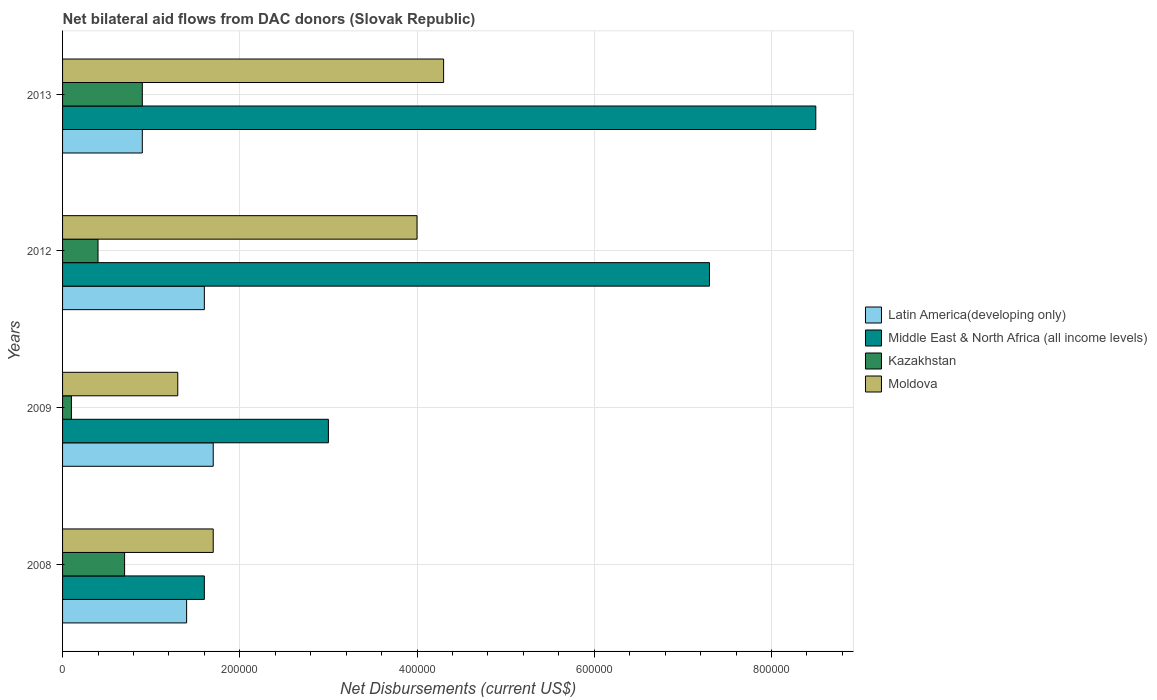How many different coloured bars are there?
Provide a short and direct response. 4. Are the number of bars per tick equal to the number of legend labels?
Give a very brief answer. Yes. Are the number of bars on each tick of the Y-axis equal?
Make the answer very short. Yes. What is the net bilateral aid flows in Middle East & North Africa (all income levels) in 2012?
Make the answer very short. 7.30e+05. Across all years, what is the minimum net bilateral aid flows in Middle East & North Africa (all income levels)?
Keep it short and to the point. 1.60e+05. What is the average net bilateral aid flows in Middle East & North Africa (all income levels) per year?
Ensure brevity in your answer.  5.10e+05. In the year 2013, what is the difference between the net bilateral aid flows in Moldova and net bilateral aid flows in Latin America(developing only)?
Provide a succinct answer. 3.40e+05. What is the ratio of the net bilateral aid flows in Moldova in 2008 to that in 2009?
Provide a succinct answer. 1.31. Is the net bilateral aid flows in Moldova in 2009 less than that in 2012?
Keep it short and to the point. Yes. Is the difference between the net bilateral aid flows in Moldova in 2009 and 2012 greater than the difference between the net bilateral aid flows in Latin America(developing only) in 2009 and 2012?
Offer a terse response. No. What is the difference between the highest and the second highest net bilateral aid flows in Moldova?
Provide a short and direct response. 3.00e+04. What does the 4th bar from the top in 2012 represents?
Make the answer very short. Latin America(developing only). What does the 3rd bar from the bottom in 2008 represents?
Make the answer very short. Kazakhstan. Is it the case that in every year, the sum of the net bilateral aid flows in Middle East & North Africa (all income levels) and net bilateral aid flows in Latin America(developing only) is greater than the net bilateral aid flows in Kazakhstan?
Keep it short and to the point. Yes. How many years are there in the graph?
Provide a short and direct response. 4. Does the graph contain any zero values?
Make the answer very short. No. Does the graph contain grids?
Make the answer very short. Yes. Where does the legend appear in the graph?
Offer a terse response. Center right. How many legend labels are there?
Make the answer very short. 4. What is the title of the graph?
Give a very brief answer. Net bilateral aid flows from DAC donors (Slovak Republic). Does "American Samoa" appear as one of the legend labels in the graph?
Provide a succinct answer. No. What is the label or title of the X-axis?
Give a very brief answer. Net Disbursements (current US$). What is the Net Disbursements (current US$) of Latin America(developing only) in 2008?
Make the answer very short. 1.40e+05. What is the Net Disbursements (current US$) in Kazakhstan in 2008?
Give a very brief answer. 7.00e+04. What is the Net Disbursements (current US$) in Moldova in 2008?
Keep it short and to the point. 1.70e+05. What is the Net Disbursements (current US$) of Latin America(developing only) in 2009?
Provide a succinct answer. 1.70e+05. What is the Net Disbursements (current US$) of Moldova in 2009?
Your response must be concise. 1.30e+05. What is the Net Disbursements (current US$) of Latin America(developing only) in 2012?
Give a very brief answer. 1.60e+05. What is the Net Disbursements (current US$) of Middle East & North Africa (all income levels) in 2012?
Provide a short and direct response. 7.30e+05. What is the Net Disbursements (current US$) of Kazakhstan in 2012?
Your response must be concise. 4.00e+04. What is the Net Disbursements (current US$) in Moldova in 2012?
Offer a very short reply. 4.00e+05. What is the Net Disbursements (current US$) of Latin America(developing only) in 2013?
Offer a very short reply. 9.00e+04. What is the Net Disbursements (current US$) of Middle East & North Africa (all income levels) in 2013?
Provide a short and direct response. 8.50e+05. What is the Net Disbursements (current US$) in Kazakhstan in 2013?
Your answer should be compact. 9.00e+04. Across all years, what is the maximum Net Disbursements (current US$) of Middle East & North Africa (all income levels)?
Provide a succinct answer. 8.50e+05. Across all years, what is the minimum Net Disbursements (current US$) in Kazakhstan?
Your response must be concise. 10000. Across all years, what is the minimum Net Disbursements (current US$) of Moldova?
Give a very brief answer. 1.30e+05. What is the total Net Disbursements (current US$) in Latin America(developing only) in the graph?
Provide a succinct answer. 5.60e+05. What is the total Net Disbursements (current US$) in Middle East & North Africa (all income levels) in the graph?
Provide a short and direct response. 2.04e+06. What is the total Net Disbursements (current US$) of Kazakhstan in the graph?
Provide a short and direct response. 2.10e+05. What is the total Net Disbursements (current US$) of Moldova in the graph?
Ensure brevity in your answer.  1.13e+06. What is the difference between the Net Disbursements (current US$) in Latin America(developing only) in 2008 and that in 2009?
Keep it short and to the point. -3.00e+04. What is the difference between the Net Disbursements (current US$) in Middle East & North Africa (all income levels) in 2008 and that in 2009?
Make the answer very short. -1.40e+05. What is the difference between the Net Disbursements (current US$) of Kazakhstan in 2008 and that in 2009?
Offer a very short reply. 6.00e+04. What is the difference between the Net Disbursements (current US$) of Latin America(developing only) in 2008 and that in 2012?
Your answer should be very brief. -2.00e+04. What is the difference between the Net Disbursements (current US$) in Middle East & North Africa (all income levels) in 2008 and that in 2012?
Provide a succinct answer. -5.70e+05. What is the difference between the Net Disbursements (current US$) in Middle East & North Africa (all income levels) in 2008 and that in 2013?
Give a very brief answer. -6.90e+05. What is the difference between the Net Disbursements (current US$) in Middle East & North Africa (all income levels) in 2009 and that in 2012?
Provide a short and direct response. -4.30e+05. What is the difference between the Net Disbursements (current US$) of Middle East & North Africa (all income levels) in 2009 and that in 2013?
Give a very brief answer. -5.50e+05. What is the difference between the Net Disbursements (current US$) in Latin America(developing only) in 2012 and that in 2013?
Keep it short and to the point. 7.00e+04. What is the difference between the Net Disbursements (current US$) in Kazakhstan in 2012 and that in 2013?
Your response must be concise. -5.00e+04. What is the difference between the Net Disbursements (current US$) of Latin America(developing only) in 2008 and the Net Disbursements (current US$) of Moldova in 2009?
Offer a terse response. 10000. What is the difference between the Net Disbursements (current US$) of Middle East & North Africa (all income levels) in 2008 and the Net Disbursements (current US$) of Kazakhstan in 2009?
Provide a succinct answer. 1.50e+05. What is the difference between the Net Disbursements (current US$) in Latin America(developing only) in 2008 and the Net Disbursements (current US$) in Middle East & North Africa (all income levels) in 2012?
Your answer should be very brief. -5.90e+05. What is the difference between the Net Disbursements (current US$) in Middle East & North Africa (all income levels) in 2008 and the Net Disbursements (current US$) in Moldova in 2012?
Make the answer very short. -2.40e+05. What is the difference between the Net Disbursements (current US$) of Kazakhstan in 2008 and the Net Disbursements (current US$) of Moldova in 2012?
Give a very brief answer. -3.30e+05. What is the difference between the Net Disbursements (current US$) in Latin America(developing only) in 2008 and the Net Disbursements (current US$) in Middle East & North Africa (all income levels) in 2013?
Your answer should be very brief. -7.10e+05. What is the difference between the Net Disbursements (current US$) of Latin America(developing only) in 2008 and the Net Disbursements (current US$) of Moldova in 2013?
Give a very brief answer. -2.90e+05. What is the difference between the Net Disbursements (current US$) of Middle East & North Africa (all income levels) in 2008 and the Net Disbursements (current US$) of Kazakhstan in 2013?
Your answer should be very brief. 7.00e+04. What is the difference between the Net Disbursements (current US$) in Kazakhstan in 2008 and the Net Disbursements (current US$) in Moldova in 2013?
Offer a very short reply. -3.60e+05. What is the difference between the Net Disbursements (current US$) of Latin America(developing only) in 2009 and the Net Disbursements (current US$) of Middle East & North Africa (all income levels) in 2012?
Ensure brevity in your answer.  -5.60e+05. What is the difference between the Net Disbursements (current US$) in Latin America(developing only) in 2009 and the Net Disbursements (current US$) in Kazakhstan in 2012?
Offer a very short reply. 1.30e+05. What is the difference between the Net Disbursements (current US$) of Middle East & North Africa (all income levels) in 2009 and the Net Disbursements (current US$) of Moldova in 2012?
Your response must be concise. -1.00e+05. What is the difference between the Net Disbursements (current US$) in Kazakhstan in 2009 and the Net Disbursements (current US$) in Moldova in 2012?
Provide a short and direct response. -3.90e+05. What is the difference between the Net Disbursements (current US$) of Latin America(developing only) in 2009 and the Net Disbursements (current US$) of Middle East & North Africa (all income levels) in 2013?
Give a very brief answer. -6.80e+05. What is the difference between the Net Disbursements (current US$) of Latin America(developing only) in 2009 and the Net Disbursements (current US$) of Moldova in 2013?
Provide a short and direct response. -2.60e+05. What is the difference between the Net Disbursements (current US$) of Middle East & North Africa (all income levels) in 2009 and the Net Disbursements (current US$) of Kazakhstan in 2013?
Ensure brevity in your answer.  2.10e+05. What is the difference between the Net Disbursements (current US$) of Kazakhstan in 2009 and the Net Disbursements (current US$) of Moldova in 2013?
Keep it short and to the point. -4.20e+05. What is the difference between the Net Disbursements (current US$) of Latin America(developing only) in 2012 and the Net Disbursements (current US$) of Middle East & North Africa (all income levels) in 2013?
Offer a very short reply. -6.90e+05. What is the difference between the Net Disbursements (current US$) in Latin America(developing only) in 2012 and the Net Disbursements (current US$) in Kazakhstan in 2013?
Your response must be concise. 7.00e+04. What is the difference between the Net Disbursements (current US$) in Middle East & North Africa (all income levels) in 2012 and the Net Disbursements (current US$) in Kazakhstan in 2013?
Provide a short and direct response. 6.40e+05. What is the difference between the Net Disbursements (current US$) in Middle East & North Africa (all income levels) in 2012 and the Net Disbursements (current US$) in Moldova in 2013?
Ensure brevity in your answer.  3.00e+05. What is the difference between the Net Disbursements (current US$) in Kazakhstan in 2012 and the Net Disbursements (current US$) in Moldova in 2013?
Give a very brief answer. -3.90e+05. What is the average Net Disbursements (current US$) of Middle East & North Africa (all income levels) per year?
Your answer should be very brief. 5.10e+05. What is the average Net Disbursements (current US$) of Kazakhstan per year?
Offer a very short reply. 5.25e+04. What is the average Net Disbursements (current US$) of Moldova per year?
Your response must be concise. 2.82e+05. In the year 2008, what is the difference between the Net Disbursements (current US$) in Latin America(developing only) and Net Disbursements (current US$) in Middle East & North Africa (all income levels)?
Your answer should be very brief. -2.00e+04. In the year 2008, what is the difference between the Net Disbursements (current US$) in Latin America(developing only) and Net Disbursements (current US$) in Kazakhstan?
Offer a terse response. 7.00e+04. In the year 2008, what is the difference between the Net Disbursements (current US$) in Latin America(developing only) and Net Disbursements (current US$) in Moldova?
Give a very brief answer. -3.00e+04. In the year 2009, what is the difference between the Net Disbursements (current US$) of Latin America(developing only) and Net Disbursements (current US$) of Middle East & North Africa (all income levels)?
Your answer should be compact. -1.30e+05. In the year 2009, what is the difference between the Net Disbursements (current US$) of Latin America(developing only) and Net Disbursements (current US$) of Kazakhstan?
Make the answer very short. 1.60e+05. In the year 2009, what is the difference between the Net Disbursements (current US$) in Middle East & North Africa (all income levels) and Net Disbursements (current US$) in Moldova?
Provide a short and direct response. 1.70e+05. In the year 2012, what is the difference between the Net Disbursements (current US$) in Latin America(developing only) and Net Disbursements (current US$) in Middle East & North Africa (all income levels)?
Give a very brief answer. -5.70e+05. In the year 2012, what is the difference between the Net Disbursements (current US$) of Latin America(developing only) and Net Disbursements (current US$) of Kazakhstan?
Your answer should be very brief. 1.20e+05. In the year 2012, what is the difference between the Net Disbursements (current US$) of Latin America(developing only) and Net Disbursements (current US$) of Moldova?
Keep it short and to the point. -2.40e+05. In the year 2012, what is the difference between the Net Disbursements (current US$) in Middle East & North Africa (all income levels) and Net Disbursements (current US$) in Kazakhstan?
Your answer should be compact. 6.90e+05. In the year 2012, what is the difference between the Net Disbursements (current US$) in Middle East & North Africa (all income levels) and Net Disbursements (current US$) in Moldova?
Offer a very short reply. 3.30e+05. In the year 2012, what is the difference between the Net Disbursements (current US$) in Kazakhstan and Net Disbursements (current US$) in Moldova?
Ensure brevity in your answer.  -3.60e+05. In the year 2013, what is the difference between the Net Disbursements (current US$) of Latin America(developing only) and Net Disbursements (current US$) of Middle East & North Africa (all income levels)?
Provide a succinct answer. -7.60e+05. In the year 2013, what is the difference between the Net Disbursements (current US$) in Latin America(developing only) and Net Disbursements (current US$) in Kazakhstan?
Your response must be concise. 0. In the year 2013, what is the difference between the Net Disbursements (current US$) of Latin America(developing only) and Net Disbursements (current US$) of Moldova?
Offer a terse response. -3.40e+05. In the year 2013, what is the difference between the Net Disbursements (current US$) in Middle East & North Africa (all income levels) and Net Disbursements (current US$) in Kazakhstan?
Keep it short and to the point. 7.60e+05. In the year 2013, what is the difference between the Net Disbursements (current US$) of Middle East & North Africa (all income levels) and Net Disbursements (current US$) of Moldova?
Ensure brevity in your answer.  4.20e+05. In the year 2013, what is the difference between the Net Disbursements (current US$) of Kazakhstan and Net Disbursements (current US$) of Moldova?
Provide a succinct answer. -3.40e+05. What is the ratio of the Net Disbursements (current US$) of Latin America(developing only) in 2008 to that in 2009?
Your response must be concise. 0.82. What is the ratio of the Net Disbursements (current US$) in Middle East & North Africa (all income levels) in 2008 to that in 2009?
Your answer should be compact. 0.53. What is the ratio of the Net Disbursements (current US$) in Moldova in 2008 to that in 2009?
Provide a short and direct response. 1.31. What is the ratio of the Net Disbursements (current US$) in Middle East & North Africa (all income levels) in 2008 to that in 2012?
Your answer should be compact. 0.22. What is the ratio of the Net Disbursements (current US$) in Kazakhstan in 2008 to that in 2012?
Provide a short and direct response. 1.75. What is the ratio of the Net Disbursements (current US$) in Moldova in 2008 to that in 2012?
Provide a short and direct response. 0.42. What is the ratio of the Net Disbursements (current US$) of Latin America(developing only) in 2008 to that in 2013?
Ensure brevity in your answer.  1.56. What is the ratio of the Net Disbursements (current US$) in Middle East & North Africa (all income levels) in 2008 to that in 2013?
Offer a terse response. 0.19. What is the ratio of the Net Disbursements (current US$) of Kazakhstan in 2008 to that in 2013?
Provide a short and direct response. 0.78. What is the ratio of the Net Disbursements (current US$) in Moldova in 2008 to that in 2013?
Your response must be concise. 0.4. What is the ratio of the Net Disbursements (current US$) in Latin America(developing only) in 2009 to that in 2012?
Your answer should be very brief. 1.06. What is the ratio of the Net Disbursements (current US$) in Middle East & North Africa (all income levels) in 2009 to that in 2012?
Your response must be concise. 0.41. What is the ratio of the Net Disbursements (current US$) in Moldova in 2009 to that in 2012?
Your response must be concise. 0.33. What is the ratio of the Net Disbursements (current US$) of Latin America(developing only) in 2009 to that in 2013?
Your answer should be very brief. 1.89. What is the ratio of the Net Disbursements (current US$) of Middle East & North Africa (all income levels) in 2009 to that in 2013?
Ensure brevity in your answer.  0.35. What is the ratio of the Net Disbursements (current US$) in Kazakhstan in 2009 to that in 2013?
Make the answer very short. 0.11. What is the ratio of the Net Disbursements (current US$) of Moldova in 2009 to that in 2013?
Your answer should be compact. 0.3. What is the ratio of the Net Disbursements (current US$) in Latin America(developing only) in 2012 to that in 2013?
Your response must be concise. 1.78. What is the ratio of the Net Disbursements (current US$) in Middle East & North Africa (all income levels) in 2012 to that in 2013?
Keep it short and to the point. 0.86. What is the ratio of the Net Disbursements (current US$) of Kazakhstan in 2012 to that in 2013?
Offer a very short reply. 0.44. What is the ratio of the Net Disbursements (current US$) in Moldova in 2012 to that in 2013?
Give a very brief answer. 0.93. What is the difference between the highest and the second highest Net Disbursements (current US$) of Moldova?
Keep it short and to the point. 3.00e+04. What is the difference between the highest and the lowest Net Disbursements (current US$) of Middle East & North Africa (all income levels)?
Your answer should be compact. 6.90e+05. 